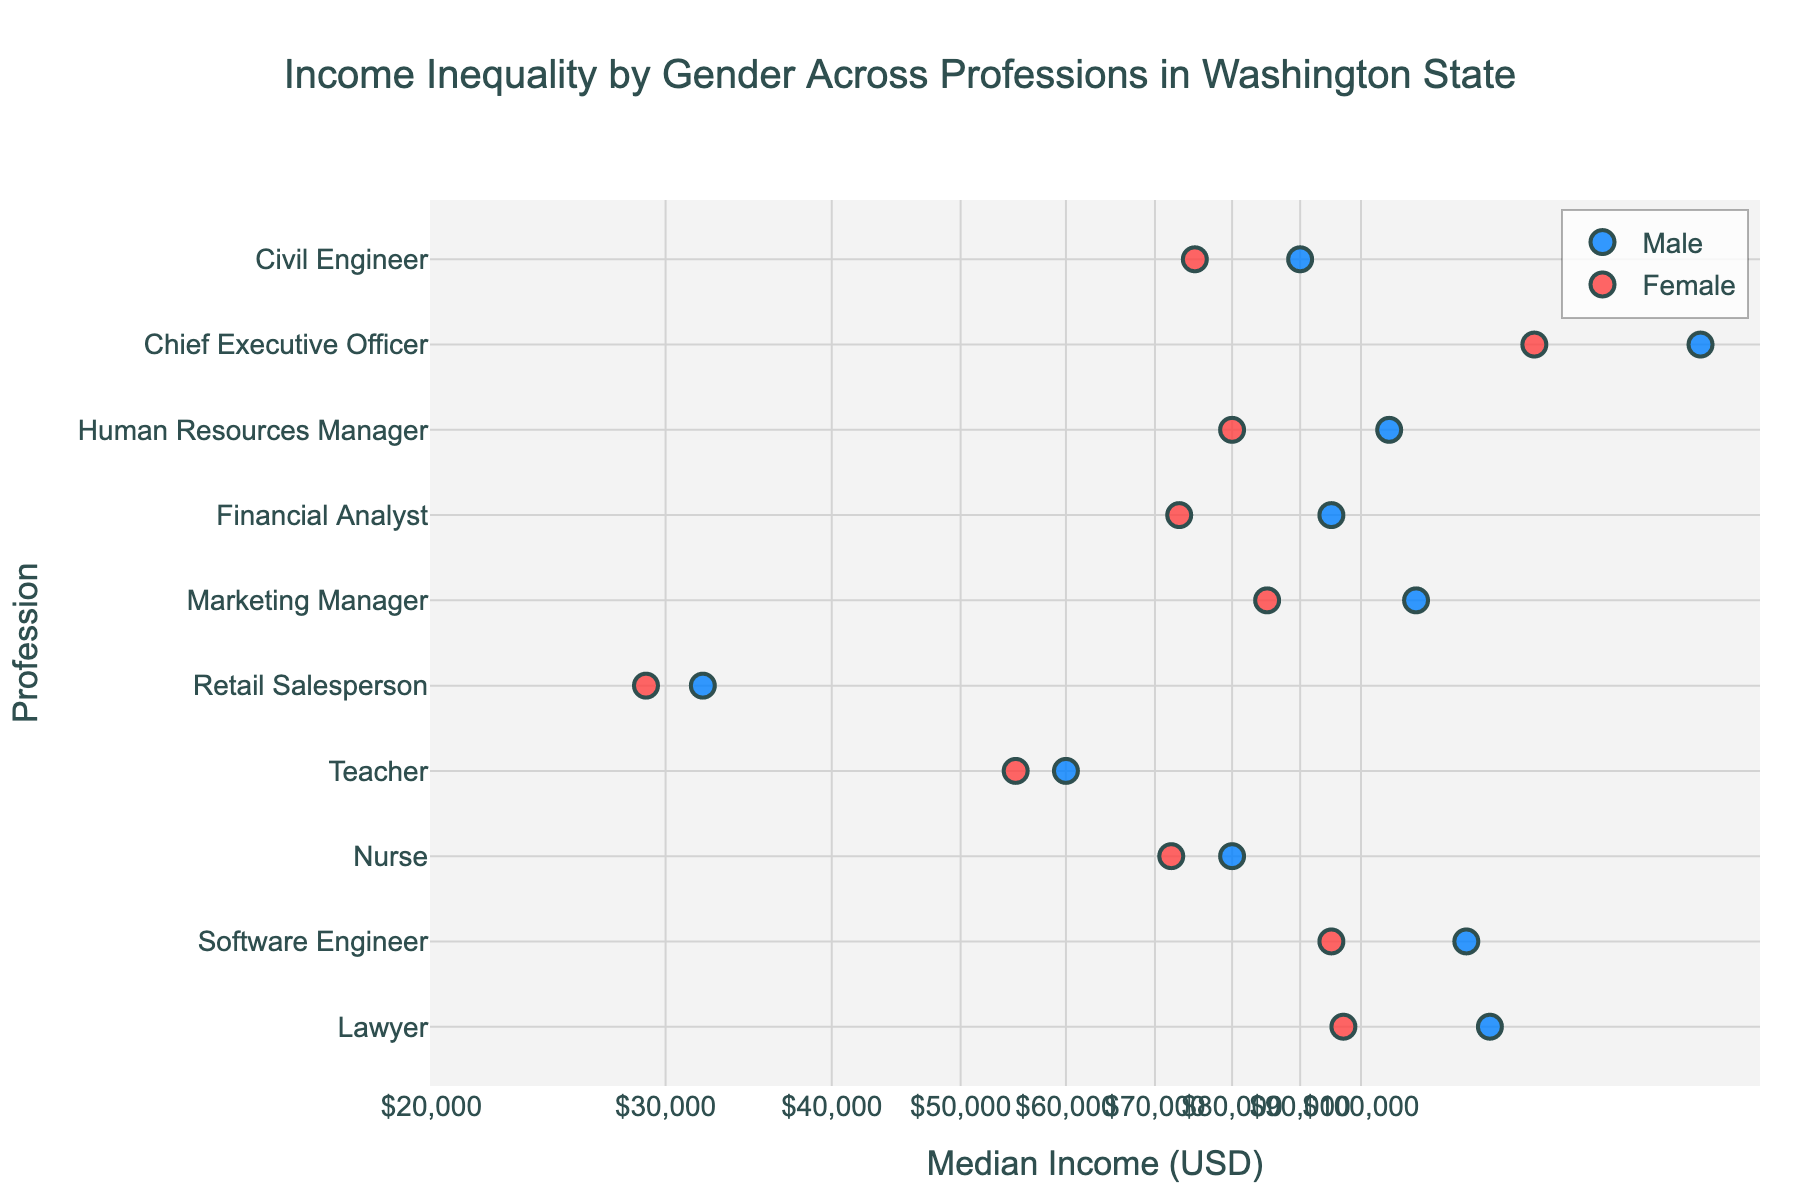What is the title of the figure? The title is located at the top center of the figure in large, distinct text. It reads "Income Inequality by Gender Across Professions in Washington State".
Answer: Income Inequality by Gender Across Professions in Washington State Which profession shows the largest median income for males? By looking at the x-axis values associated with the blue markers (representing males), the farthest right marker represents the highest median income for males. In this case, it's the "Chief Executive Officer".
Answer: Chief Executive Officer What is the median income for female Lawyers? Locate the red marker corresponding to the profession "Lawyer" on the y-axis and trace it directly to the x-axis which represents the median income. It shows a value of 97,000 dollars.
Answer: $97,000 Which profession has the smallest gender income gap? To identify the smallest gap, look for the profession where the blue and red markers are closest to each other on the x-axis. This occurs in the "Nurse" profession.
Answer: Nurse What is the difference in median income between male and female Marketing Managers? Locate the blue and red markers for "Marketing Manager". Note the median incomes (110,000 for males and 85,000 for females). Subtract the female income from the male income: 110,000 - 85,000 = 25,000.
Answer: $25,000 How many professions show a median income above $100,000 for males? Identify blue markers that are located beyond the $100,000 mark on the x-axis. The applicable professions are: Lawyer, Software Engineer, Marketing Manager, Human Resources Manager, and Chief Executive Officer, totaling 5 professions.
Answer: 5 Which profession has the widest income inequality by gender? Look for the profession where the distance between the blue and red markers on the x-axis is the greatest. The profession with the greatest distance (widest inequality) is "Chief Executive Officer".
Answer: Chief Executive Officer What is the log-transformed value of the median income for male Software Engineers? The median income for male Software Engineers is $120,000. On a log scale, the log10 value of 120,000 is approximately 5.08.
Answer: 5.08 Which gender has a higher median income among Financial Analysts? Compare the positions of blue and red markers for "Financial Analyst". The blue marker (male) is further right compared to the red marker (female), indicating higher median income for males.
Answer: Male Do teachers have a higher or lower median income than nurses for both genders? Compare the positions of markers for "Teacher" and "Nurse" on the x-axis. Both blue and red markers for "Nurse" are further right than those for "Teacher", indicating nurses have higher median income for both genders.
Answer: Lower 